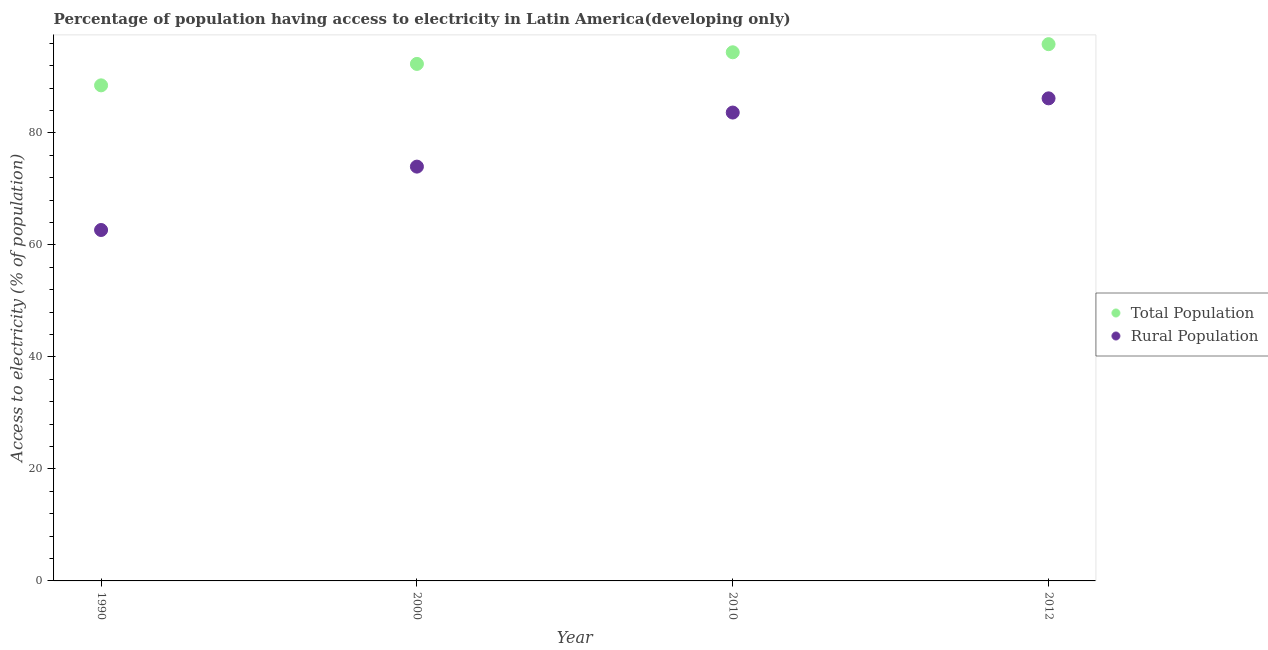Is the number of dotlines equal to the number of legend labels?
Offer a terse response. Yes. What is the percentage of population having access to electricity in 1990?
Give a very brief answer. 88.48. Across all years, what is the maximum percentage of population having access to electricity?
Keep it short and to the point. 95.83. Across all years, what is the minimum percentage of rural population having access to electricity?
Keep it short and to the point. 62.65. In which year was the percentage of population having access to electricity minimum?
Your answer should be compact. 1990. What is the total percentage of rural population having access to electricity in the graph?
Make the answer very short. 306.39. What is the difference between the percentage of population having access to electricity in 2010 and that in 2012?
Offer a very short reply. -1.45. What is the difference between the percentage of population having access to electricity in 1990 and the percentage of rural population having access to electricity in 2000?
Offer a terse response. 14.51. What is the average percentage of rural population having access to electricity per year?
Give a very brief answer. 76.6. In the year 2000, what is the difference between the percentage of population having access to electricity and percentage of rural population having access to electricity?
Ensure brevity in your answer.  18.34. What is the ratio of the percentage of rural population having access to electricity in 1990 to that in 2012?
Offer a terse response. 0.73. Is the percentage of population having access to electricity in 2000 less than that in 2010?
Ensure brevity in your answer.  Yes. What is the difference between the highest and the second highest percentage of rural population having access to electricity?
Your answer should be very brief. 2.53. What is the difference between the highest and the lowest percentage of rural population having access to electricity?
Your response must be concise. 23.5. In how many years, is the percentage of rural population having access to electricity greater than the average percentage of rural population having access to electricity taken over all years?
Offer a very short reply. 2. Is the sum of the percentage of population having access to electricity in 1990 and 2000 greater than the maximum percentage of rural population having access to electricity across all years?
Offer a very short reply. Yes. How many dotlines are there?
Ensure brevity in your answer.  2. What is the difference between two consecutive major ticks on the Y-axis?
Keep it short and to the point. 20. Are the values on the major ticks of Y-axis written in scientific E-notation?
Keep it short and to the point. No. Does the graph contain any zero values?
Offer a terse response. No. How many legend labels are there?
Offer a terse response. 2. How are the legend labels stacked?
Your answer should be very brief. Vertical. What is the title of the graph?
Offer a terse response. Percentage of population having access to electricity in Latin America(developing only). What is the label or title of the X-axis?
Offer a terse response. Year. What is the label or title of the Y-axis?
Provide a short and direct response. Access to electricity (% of population). What is the Access to electricity (% of population) in Total Population in 1990?
Your answer should be compact. 88.48. What is the Access to electricity (% of population) of Rural Population in 1990?
Your answer should be compact. 62.65. What is the Access to electricity (% of population) of Total Population in 2000?
Your response must be concise. 92.3. What is the Access to electricity (% of population) of Rural Population in 2000?
Make the answer very short. 73.97. What is the Access to electricity (% of population) of Total Population in 2010?
Your answer should be very brief. 94.38. What is the Access to electricity (% of population) of Rural Population in 2010?
Offer a terse response. 83.62. What is the Access to electricity (% of population) of Total Population in 2012?
Make the answer very short. 95.83. What is the Access to electricity (% of population) of Rural Population in 2012?
Offer a terse response. 86.15. Across all years, what is the maximum Access to electricity (% of population) of Total Population?
Keep it short and to the point. 95.83. Across all years, what is the maximum Access to electricity (% of population) of Rural Population?
Offer a very short reply. 86.15. Across all years, what is the minimum Access to electricity (% of population) in Total Population?
Give a very brief answer. 88.48. Across all years, what is the minimum Access to electricity (% of population) of Rural Population?
Ensure brevity in your answer.  62.65. What is the total Access to electricity (% of population) in Total Population in the graph?
Offer a very short reply. 370.99. What is the total Access to electricity (% of population) of Rural Population in the graph?
Your response must be concise. 306.39. What is the difference between the Access to electricity (% of population) in Total Population in 1990 and that in 2000?
Your answer should be compact. -3.83. What is the difference between the Access to electricity (% of population) of Rural Population in 1990 and that in 2000?
Give a very brief answer. -11.32. What is the difference between the Access to electricity (% of population) in Total Population in 1990 and that in 2010?
Give a very brief answer. -5.9. What is the difference between the Access to electricity (% of population) of Rural Population in 1990 and that in 2010?
Your response must be concise. -20.97. What is the difference between the Access to electricity (% of population) in Total Population in 1990 and that in 2012?
Make the answer very short. -7.35. What is the difference between the Access to electricity (% of population) in Rural Population in 1990 and that in 2012?
Provide a short and direct response. -23.5. What is the difference between the Access to electricity (% of population) of Total Population in 2000 and that in 2010?
Keep it short and to the point. -2.07. What is the difference between the Access to electricity (% of population) of Rural Population in 2000 and that in 2010?
Give a very brief answer. -9.65. What is the difference between the Access to electricity (% of population) in Total Population in 2000 and that in 2012?
Make the answer very short. -3.52. What is the difference between the Access to electricity (% of population) in Rural Population in 2000 and that in 2012?
Offer a very short reply. -12.19. What is the difference between the Access to electricity (% of population) of Total Population in 2010 and that in 2012?
Your answer should be very brief. -1.45. What is the difference between the Access to electricity (% of population) of Rural Population in 2010 and that in 2012?
Offer a very short reply. -2.53. What is the difference between the Access to electricity (% of population) in Total Population in 1990 and the Access to electricity (% of population) in Rural Population in 2000?
Provide a short and direct response. 14.51. What is the difference between the Access to electricity (% of population) of Total Population in 1990 and the Access to electricity (% of population) of Rural Population in 2010?
Offer a terse response. 4.86. What is the difference between the Access to electricity (% of population) in Total Population in 1990 and the Access to electricity (% of population) in Rural Population in 2012?
Provide a succinct answer. 2.32. What is the difference between the Access to electricity (% of population) in Total Population in 2000 and the Access to electricity (% of population) in Rural Population in 2010?
Your response must be concise. 8.68. What is the difference between the Access to electricity (% of population) of Total Population in 2000 and the Access to electricity (% of population) of Rural Population in 2012?
Provide a succinct answer. 6.15. What is the difference between the Access to electricity (% of population) of Total Population in 2010 and the Access to electricity (% of population) of Rural Population in 2012?
Your answer should be very brief. 8.22. What is the average Access to electricity (% of population) in Total Population per year?
Ensure brevity in your answer.  92.75. What is the average Access to electricity (% of population) in Rural Population per year?
Your response must be concise. 76.6. In the year 1990, what is the difference between the Access to electricity (% of population) of Total Population and Access to electricity (% of population) of Rural Population?
Keep it short and to the point. 25.82. In the year 2000, what is the difference between the Access to electricity (% of population) in Total Population and Access to electricity (% of population) in Rural Population?
Provide a short and direct response. 18.34. In the year 2010, what is the difference between the Access to electricity (% of population) of Total Population and Access to electricity (% of population) of Rural Population?
Keep it short and to the point. 10.76. In the year 2012, what is the difference between the Access to electricity (% of population) in Total Population and Access to electricity (% of population) in Rural Population?
Provide a succinct answer. 9.68. What is the ratio of the Access to electricity (% of population) in Total Population in 1990 to that in 2000?
Your answer should be very brief. 0.96. What is the ratio of the Access to electricity (% of population) in Rural Population in 1990 to that in 2000?
Make the answer very short. 0.85. What is the ratio of the Access to electricity (% of population) of Total Population in 1990 to that in 2010?
Provide a short and direct response. 0.94. What is the ratio of the Access to electricity (% of population) in Rural Population in 1990 to that in 2010?
Offer a terse response. 0.75. What is the ratio of the Access to electricity (% of population) of Total Population in 1990 to that in 2012?
Make the answer very short. 0.92. What is the ratio of the Access to electricity (% of population) in Rural Population in 1990 to that in 2012?
Offer a terse response. 0.73. What is the ratio of the Access to electricity (% of population) in Rural Population in 2000 to that in 2010?
Make the answer very short. 0.88. What is the ratio of the Access to electricity (% of population) in Total Population in 2000 to that in 2012?
Ensure brevity in your answer.  0.96. What is the ratio of the Access to electricity (% of population) in Rural Population in 2000 to that in 2012?
Offer a very short reply. 0.86. What is the ratio of the Access to electricity (% of population) of Total Population in 2010 to that in 2012?
Your answer should be very brief. 0.98. What is the ratio of the Access to electricity (% of population) of Rural Population in 2010 to that in 2012?
Make the answer very short. 0.97. What is the difference between the highest and the second highest Access to electricity (% of population) in Total Population?
Your answer should be very brief. 1.45. What is the difference between the highest and the second highest Access to electricity (% of population) of Rural Population?
Offer a terse response. 2.53. What is the difference between the highest and the lowest Access to electricity (% of population) of Total Population?
Your answer should be very brief. 7.35. What is the difference between the highest and the lowest Access to electricity (% of population) of Rural Population?
Provide a short and direct response. 23.5. 